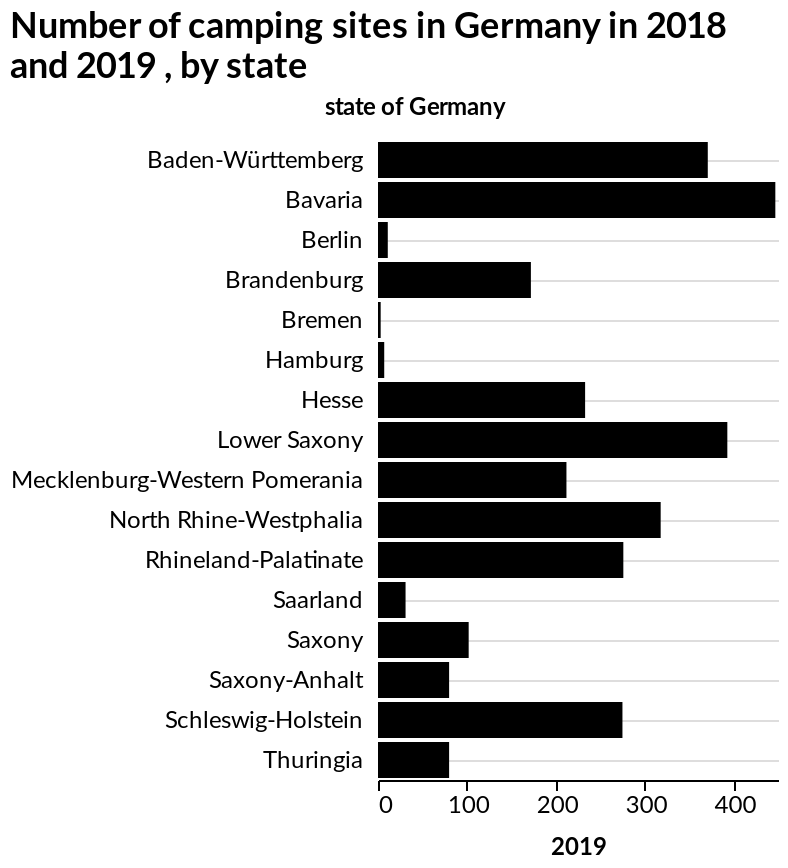<image>
Which state had the second-lowest number of camping sites? The information doesn't provide data on the second-lowest number of camping sites among the states. Offer a thorough analysis of the image. There is a wide variety in the number of camp sites in each state. The state with the highest number of camp sites is Bavaria and the state with the lowest number of camp sites is Breman. What type of graph is being used to represent the data? The graph used is a bar graph. What state had the lowest number of camping sites?  Bremen 